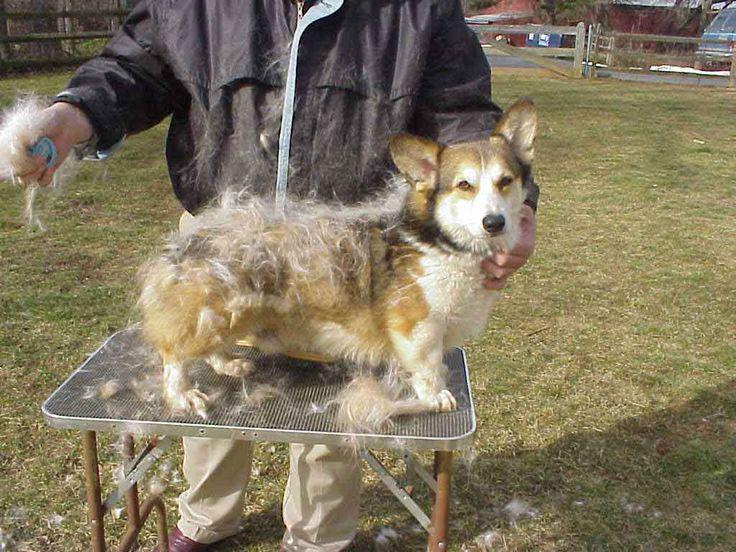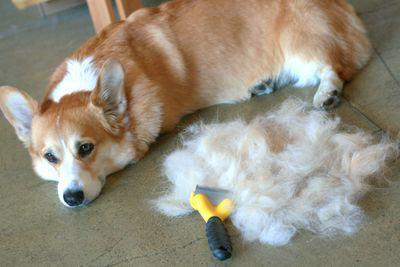The first image is the image on the left, the second image is the image on the right. Considering the images on both sides, is "The dog in the image on the right has its mouth open." valid? Answer yes or no. No. The first image is the image on the left, the second image is the image on the right. Given the left and right images, does the statement "The left image shows a corgi sitting on green grass behind a mound of pale dog fir." hold true? Answer yes or no. No. 